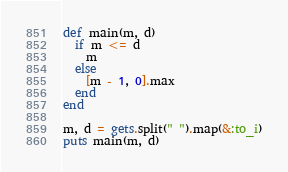<code> <loc_0><loc_0><loc_500><loc_500><_Ruby_>def main(m, d)
  if m <= d
    m
  else
    [m - 1, 0].max
  end
end

m, d = gets.split(" ").map(&:to_i)
puts main(m, d)</code> 